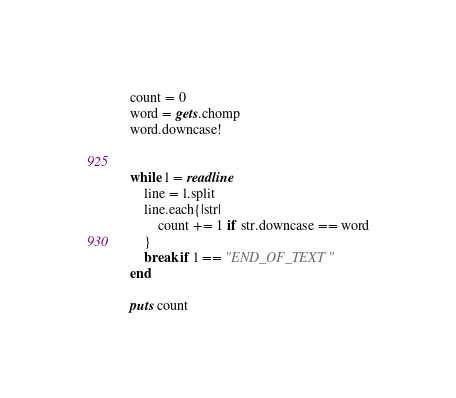<code> <loc_0><loc_0><loc_500><loc_500><_Ruby_>count = 0
word = gets.chomp
word.downcase!


while l = readline
    line = l.split
    line.each{|str|
        count += 1 if str.downcase == word
    }
    break if l == "END_OF_TEXT"
end

puts count

</code> 